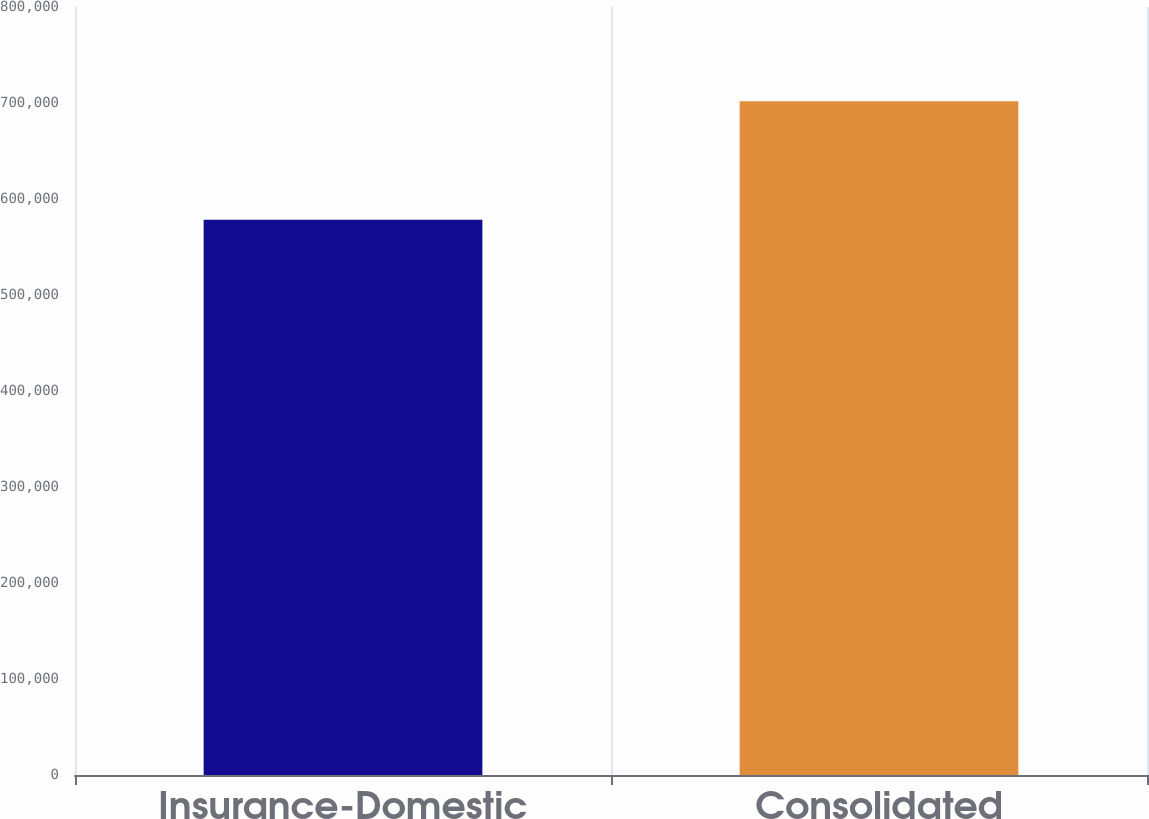Convert chart to OTSL. <chart><loc_0><loc_0><loc_500><loc_500><bar_chart><fcel>Insurance-Domestic<fcel>Consolidated<nl><fcel>578500<fcel>701928<nl></chart> 